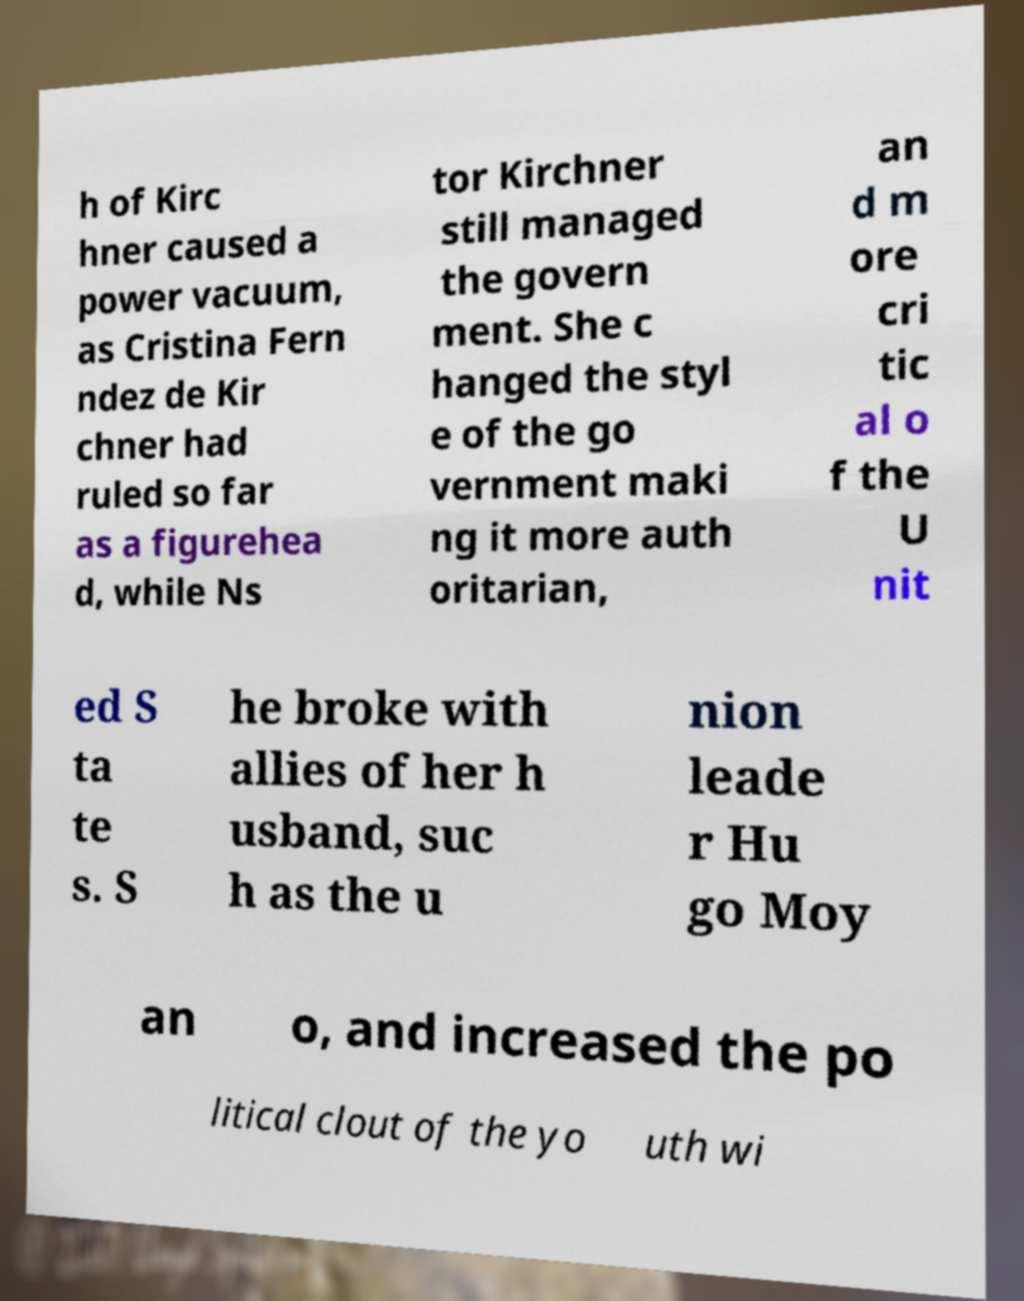Please read and relay the text visible in this image. What does it say? h of Kirc hner caused a power vacuum, as Cristina Fern ndez de Kir chner had ruled so far as a figurehea d, while Ns tor Kirchner still managed the govern ment. She c hanged the styl e of the go vernment maki ng it more auth oritarian, an d m ore cri tic al o f the U nit ed S ta te s. S he broke with allies of her h usband, suc h as the u nion leade r Hu go Moy an o, and increased the po litical clout of the yo uth wi 